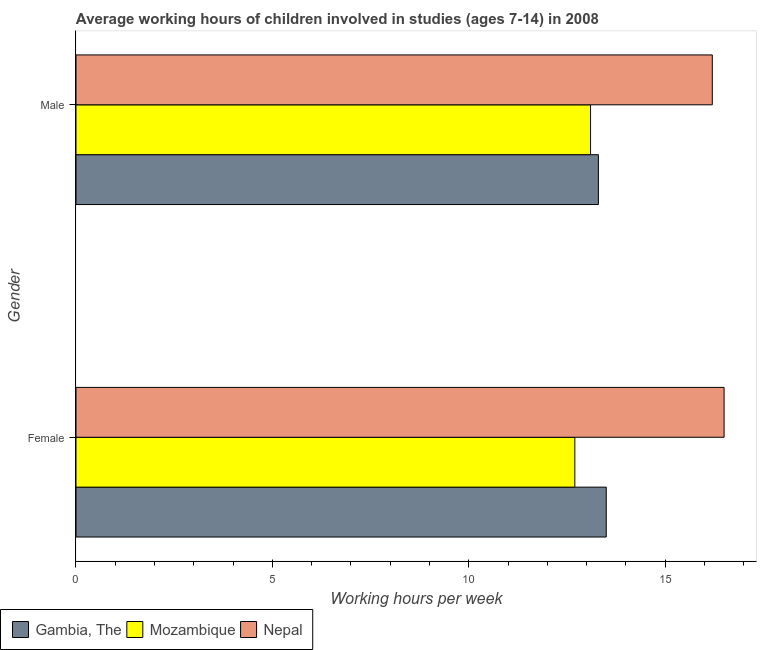What is the average working hour of male children in Mozambique?
Offer a terse response. 13.1. Across all countries, what is the minimum average working hour of female children?
Ensure brevity in your answer.  12.7. In which country was the average working hour of female children maximum?
Offer a very short reply. Nepal. In which country was the average working hour of female children minimum?
Give a very brief answer. Mozambique. What is the total average working hour of female children in the graph?
Ensure brevity in your answer.  42.7. What is the difference between the average working hour of female children in Mozambique and that in Nepal?
Keep it short and to the point. -3.8. What is the difference between the average working hour of male children in Gambia, The and the average working hour of female children in Mozambique?
Make the answer very short. 0.6. What is the average average working hour of male children per country?
Give a very brief answer. 14.2. What is the difference between the average working hour of male children and average working hour of female children in Gambia, The?
Ensure brevity in your answer.  -0.2. What is the ratio of the average working hour of male children in Nepal to that in Gambia, The?
Your response must be concise. 1.22. What does the 2nd bar from the top in Female represents?
Your response must be concise. Mozambique. What does the 1st bar from the bottom in Female represents?
Your response must be concise. Gambia, The. Are all the bars in the graph horizontal?
Keep it short and to the point. Yes. What is the difference between two consecutive major ticks on the X-axis?
Offer a very short reply. 5. How many legend labels are there?
Give a very brief answer. 3. What is the title of the graph?
Offer a terse response. Average working hours of children involved in studies (ages 7-14) in 2008. What is the label or title of the X-axis?
Your response must be concise. Working hours per week. What is the Working hours per week of Gambia, The in Female?
Make the answer very short. 13.5. What is the Working hours per week of Mozambique in Male?
Make the answer very short. 13.1. Across all Gender, what is the maximum Working hours per week in Gambia, The?
Provide a succinct answer. 13.5. Across all Gender, what is the minimum Working hours per week in Nepal?
Offer a very short reply. 16.2. What is the total Working hours per week in Gambia, The in the graph?
Ensure brevity in your answer.  26.8. What is the total Working hours per week in Mozambique in the graph?
Give a very brief answer. 25.8. What is the total Working hours per week of Nepal in the graph?
Your response must be concise. 32.7. What is the difference between the Working hours per week in Mozambique in Female and that in Male?
Your answer should be very brief. -0.4. What is the difference between the Working hours per week of Gambia, The in Female and the Working hours per week of Mozambique in Male?
Make the answer very short. 0.4. What is the average Working hours per week in Nepal per Gender?
Provide a short and direct response. 16.35. What is the difference between the Working hours per week in Gambia, The and Working hours per week in Mozambique in Female?
Your response must be concise. 0.8. What is the difference between the Working hours per week of Gambia, The and Working hours per week of Nepal in Female?
Give a very brief answer. -3. What is the difference between the Working hours per week of Gambia, The and Working hours per week of Mozambique in Male?
Provide a succinct answer. 0.2. What is the difference between the Working hours per week in Gambia, The and Working hours per week in Nepal in Male?
Your answer should be compact. -2.9. What is the ratio of the Working hours per week in Mozambique in Female to that in Male?
Provide a short and direct response. 0.97. What is the ratio of the Working hours per week in Nepal in Female to that in Male?
Provide a succinct answer. 1.02. What is the difference between the highest and the second highest Working hours per week of Mozambique?
Offer a very short reply. 0.4. What is the difference between the highest and the lowest Working hours per week of Gambia, The?
Provide a succinct answer. 0.2. What is the difference between the highest and the lowest Working hours per week of Mozambique?
Your answer should be very brief. 0.4. 